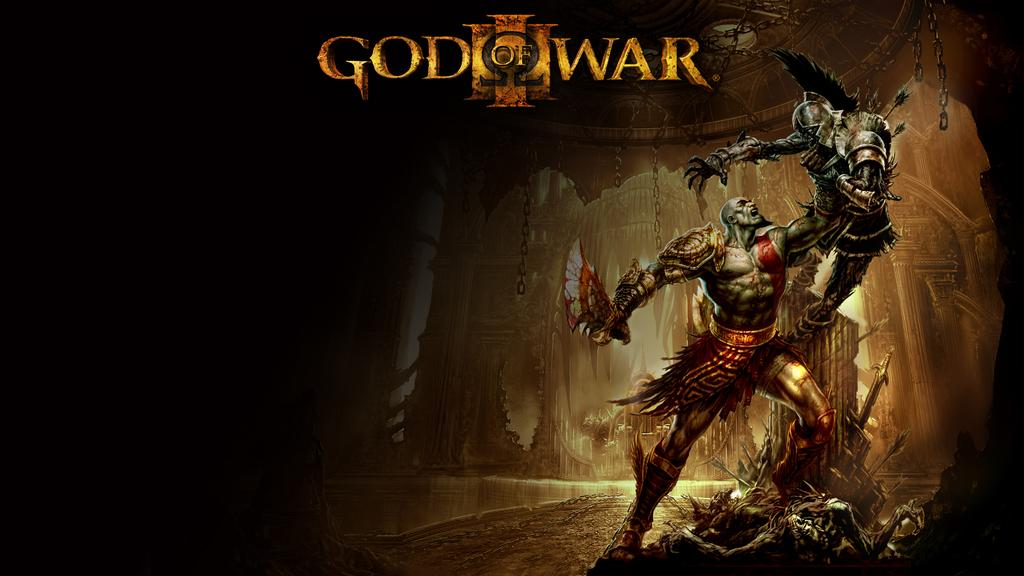Provide a one-sentence caption for the provided image. The cover of a video game called God Of War depicting two warriors fighting. 